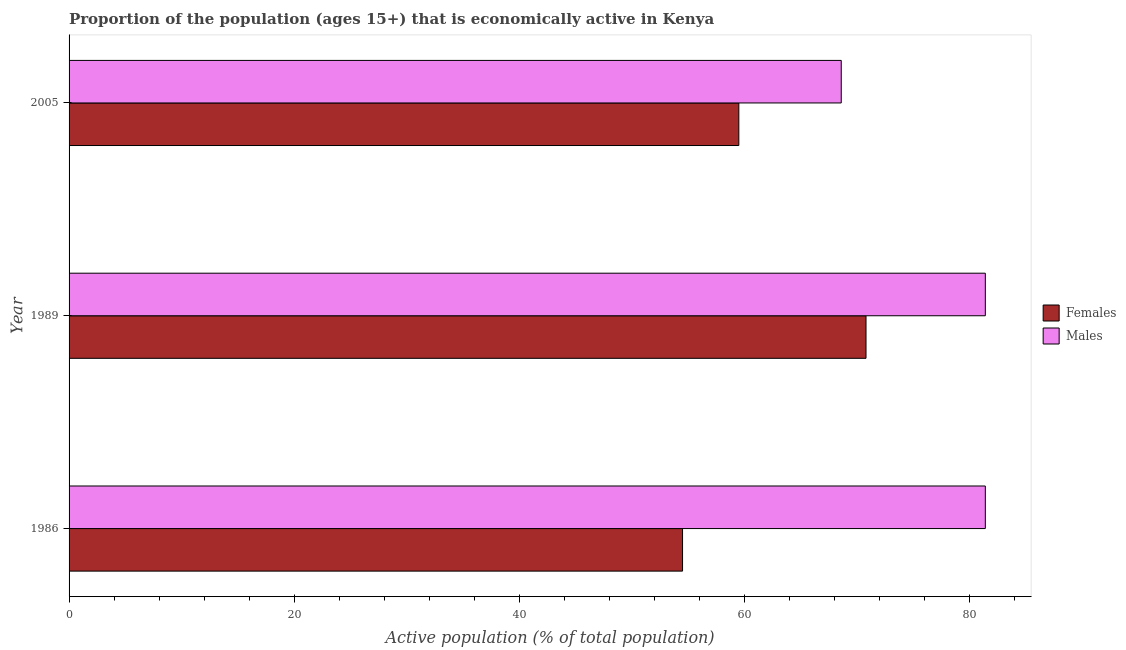Are the number of bars on each tick of the Y-axis equal?
Ensure brevity in your answer.  Yes. In how many cases, is the number of bars for a given year not equal to the number of legend labels?
Your answer should be compact. 0. What is the percentage of economically active male population in 1989?
Make the answer very short. 81.4. Across all years, what is the maximum percentage of economically active male population?
Your answer should be very brief. 81.4. Across all years, what is the minimum percentage of economically active male population?
Provide a succinct answer. 68.6. In which year was the percentage of economically active male population maximum?
Provide a short and direct response. 1986. What is the total percentage of economically active male population in the graph?
Offer a terse response. 231.4. What is the difference between the percentage of economically active female population in 1989 and the percentage of economically active male population in 1986?
Your response must be concise. -10.6. What is the average percentage of economically active female population per year?
Offer a very short reply. 61.6. In the year 1989, what is the difference between the percentage of economically active female population and percentage of economically active male population?
Provide a short and direct response. -10.6. In how many years, is the percentage of economically active male population greater than 20 %?
Keep it short and to the point. 3. What is the ratio of the percentage of economically active male population in 1986 to that in 2005?
Provide a succinct answer. 1.19. Is the percentage of economically active male population in 1986 less than that in 1989?
Offer a terse response. No. Is the difference between the percentage of economically active female population in 1986 and 2005 greater than the difference between the percentage of economically active male population in 1986 and 2005?
Give a very brief answer. No. What is the difference between the highest and the second highest percentage of economically active male population?
Your response must be concise. 0. Is the sum of the percentage of economically active female population in 1986 and 2005 greater than the maximum percentage of economically active male population across all years?
Keep it short and to the point. Yes. What does the 1st bar from the top in 2005 represents?
Your answer should be compact. Males. What does the 2nd bar from the bottom in 2005 represents?
Ensure brevity in your answer.  Males. How many bars are there?
Make the answer very short. 6. Are all the bars in the graph horizontal?
Keep it short and to the point. Yes. Are the values on the major ticks of X-axis written in scientific E-notation?
Ensure brevity in your answer.  No. Does the graph contain any zero values?
Provide a succinct answer. No. Does the graph contain grids?
Offer a terse response. No. How many legend labels are there?
Provide a succinct answer. 2. How are the legend labels stacked?
Offer a very short reply. Vertical. What is the title of the graph?
Provide a short and direct response. Proportion of the population (ages 15+) that is economically active in Kenya. What is the label or title of the X-axis?
Keep it short and to the point. Active population (% of total population). What is the label or title of the Y-axis?
Provide a succinct answer. Year. What is the Active population (% of total population) in Females in 1986?
Give a very brief answer. 54.5. What is the Active population (% of total population) of Males in 1986?
Offer a terse response. 81.4. What is the Active population (% of total population) in Females in 1989?
Your answer should be compact. 70.8. What is the Active population (% of total population) of Males in 1989?
Offer a very short reply. 81.4. What is the Active population (% of total population) of Females in 2005?
Make the answer very short. 59.5. What is the Active population (% of total population) in Males in 2005?
Your answer should be very brief. 68.6. Across all years, what is the maximum Active population (% of total population) in Females?
Your answer should be compact. 70.8. Across all years, what is the maximum Active population (% of total population) of Males?
Offer a very short reply. 81.4. Across all years, what is the minimum Active population (% of total population) of Females?
Ensure brevity in your answer.  54.5. Across all years, what is the minimum Active population (% of total population) in Males?
Your answer should be very brief. 68.6. What is the total Active population (% of total population) of Females in the graph?
Ensure brevity in your answer.  184.8. What is the total Active population (% of total population) in Males in the graph?
Provide a succinct answer. 231.4. What is the difference between the Active population (% of total population) of Females in 1986 and that in 1989?
Your answer should be compact. -16.3. What is the difference between the Active population (% of total population) in Males in 1986 and that in 1989?
Keep it short and to the point. 0. What is the difference between the Active population (% of total population) of Females in 1986 and that in 2005?
Your answer should be compact. -5. What is the difference between the Active population (% of total population) in Females in 1989 and that in 2005?
Your response must be concise. 11.3. What is the difference between the Active population (% of total population) of Males in 1989 and that in 2005?
Make the answer very short. 12.8. What is the difference between the Active population (% of total population) in Females in 1986 and the Active population (% of total population) in Males in 1989?
Your response must be concise. -26.9. What is the difference between the Active population (% of total population) in Females in 1986 and the Active population (% of total population) in Males in 2005?
Provide a succinct answer. -14.1. What is the average Active population (% of total population) of Females per year?
Provide a short and direct response. 61.6. What is the average Active population (% of total population) in Males per year?
Provide a short and direct response. 77.13. In the year 1986, what is the difference between the Active population (% of total population) of Females and Active population (% of total population) of Males?
Your answer should be very brief. -26.9. In the year 1989, what is the difference between the Active population (% of total population) of Females and Active population (% of total population) of Males?
Your response must be concise. -10.6. In the year 2005, what is the difference between the Active population (% of total population) of Females and Active population (% of total population) of Males?
Provide a succinct answer. -9.1. What is the ratio of the Active population (% of total population) of Females in 1986 to that in 1989?
Keep it short and to the point. 0.77. What is the ratio of the Active population (% of total population) of Males in 1986 to that in 1989?
Your answer should be compact. 1. What is the ratio of the Active population (% of total population) of Females in 1986 to that in 2005?
Your answer should be compact. 0.92. What is the ratio of the Active population (% of total population) of Males in 1986 to that in 2005?
Keep it short and to the point. 1.19. What is the ratio of the Active population (% of total population) of Females in 1989 to that in 2005?
Keep it short and to the point. 1.19. What is the ratio of the Active population (% of total population) of Males in 1989 to that in 2005?
Your answer should be compact. 1.19. What is the difference between the highest and the lowest Active population (% of total population) of Females?
Provide a short and direct response. 16.3. 